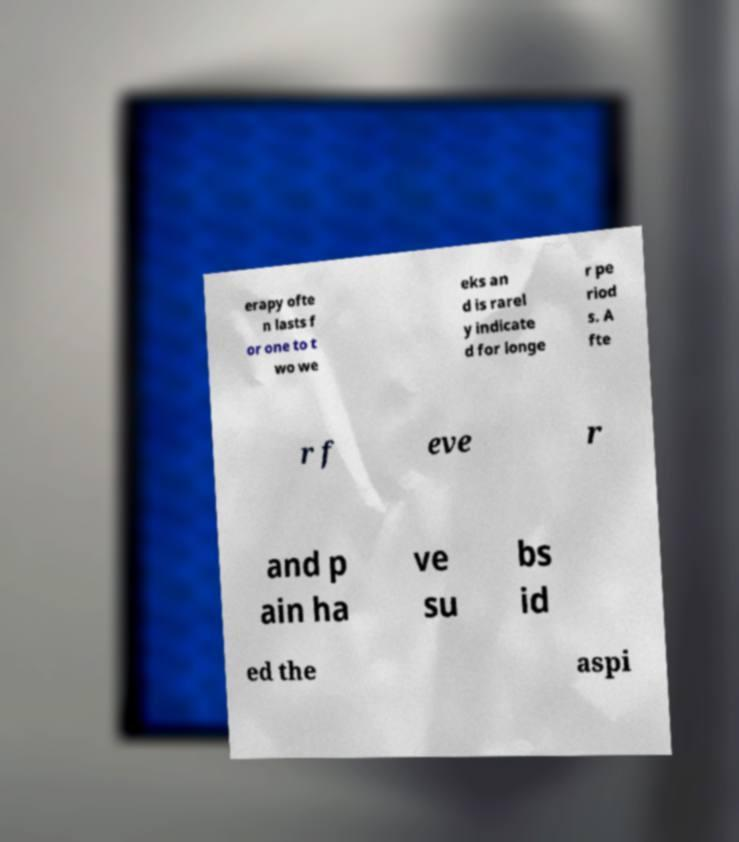Could you assist in decoding the text presented in this image and type it out clearly? erapy ofte n lasts f or one to t wo we eks an d is rarel y indicate d for longe r pe riod s. A fte r f eve r and p ain ha ve su bs id ed the aspi 